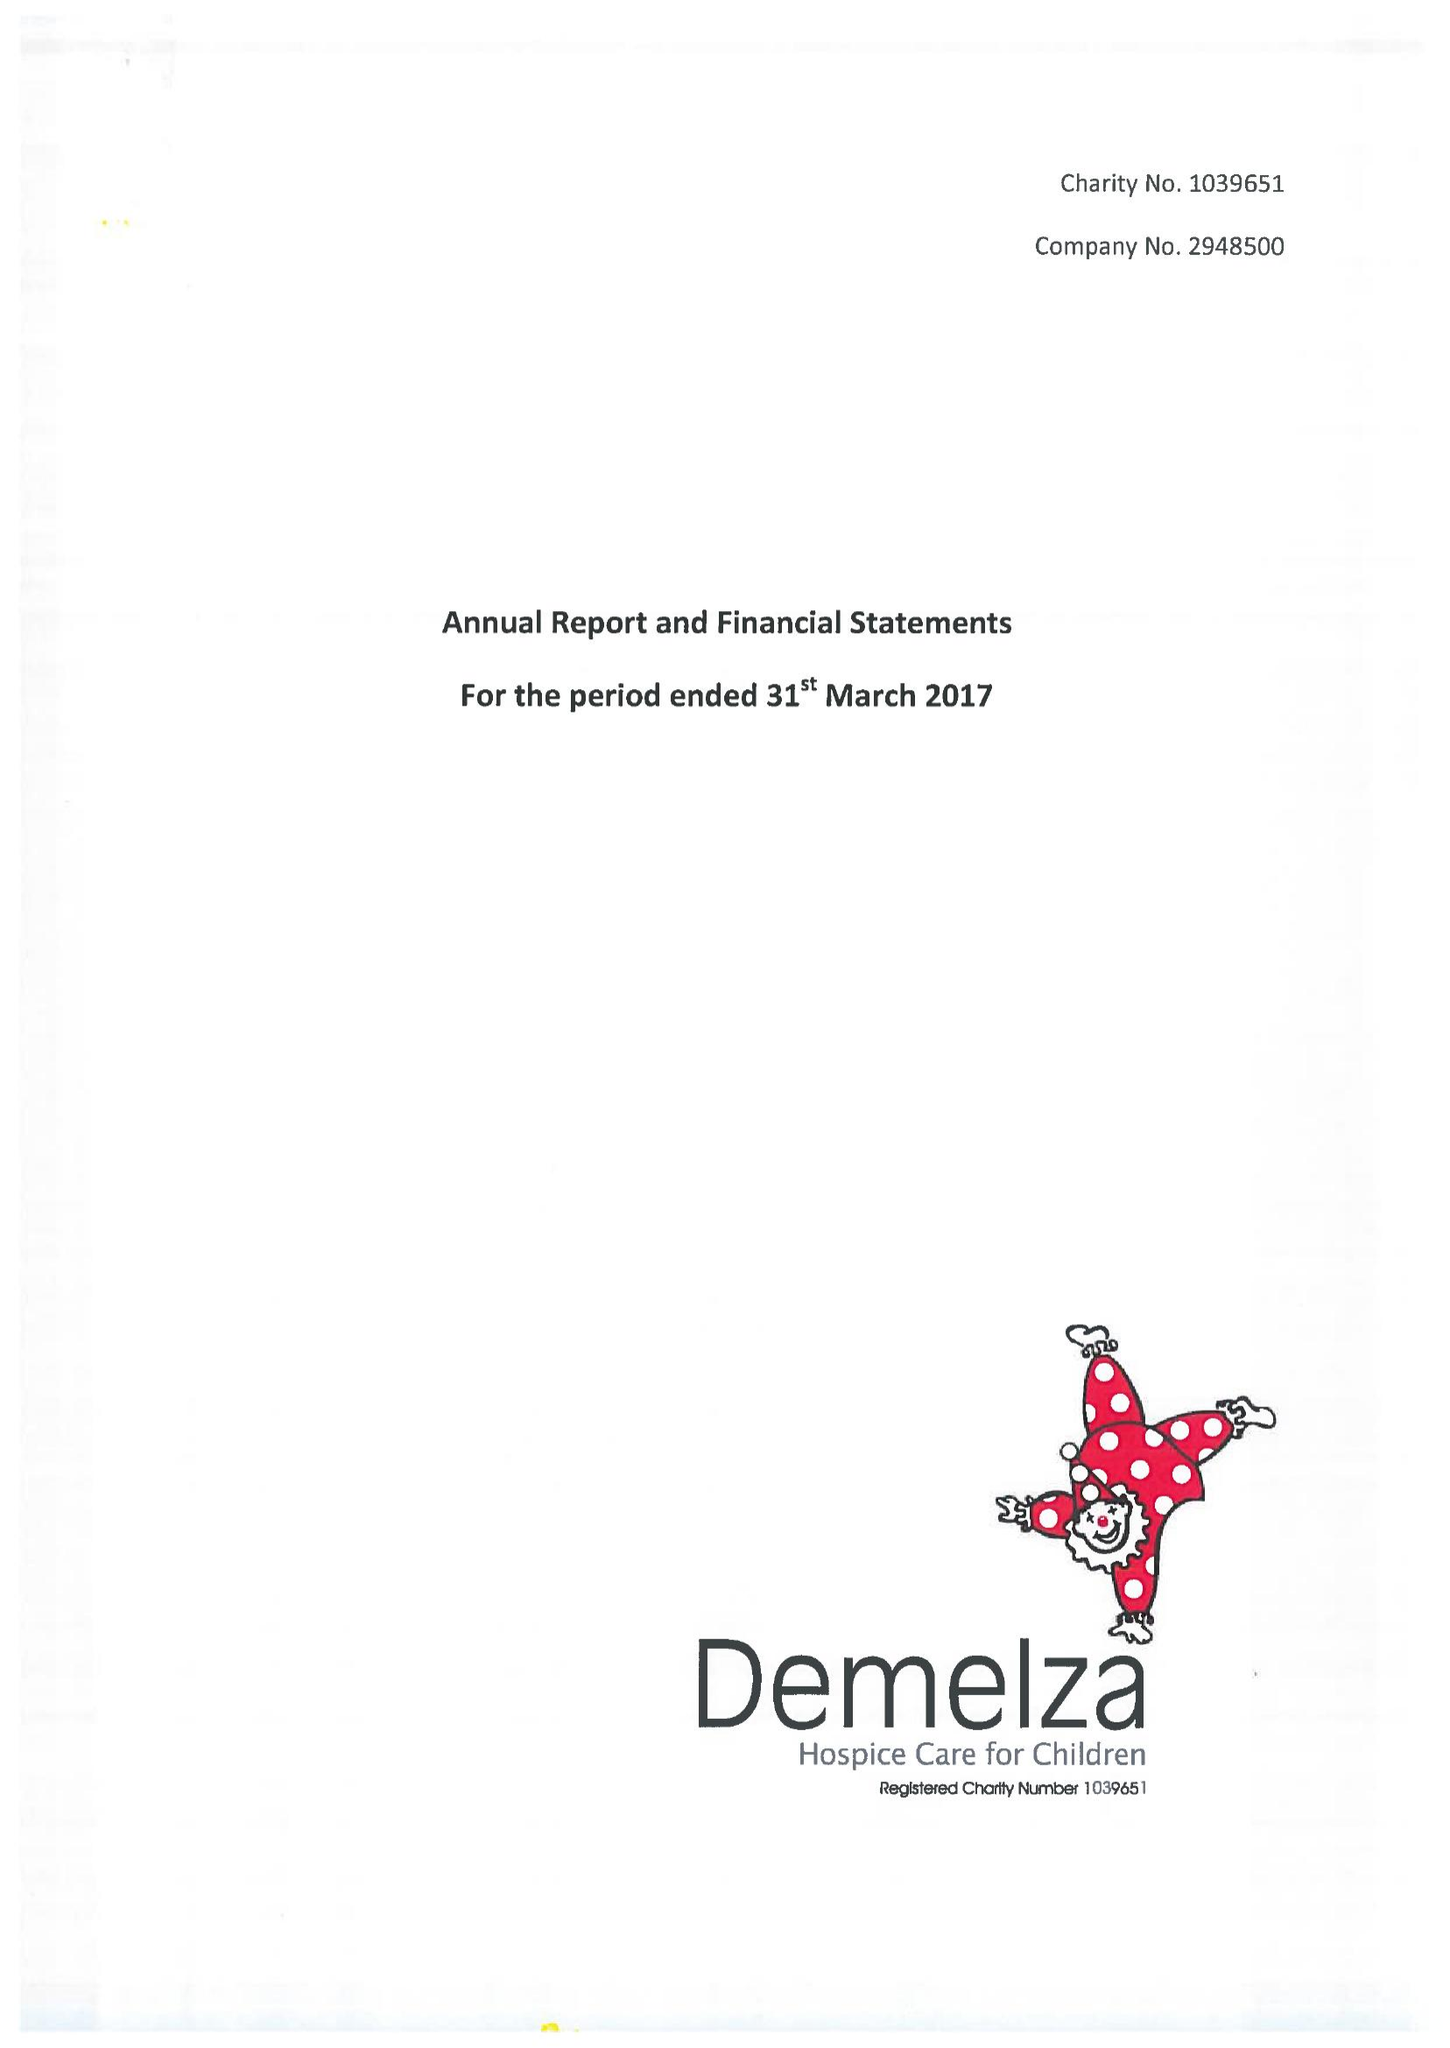What is the value for the report_date?
Answer the question using a single word or phrase. 2017-03-31 